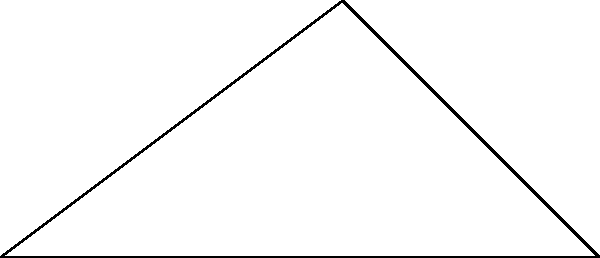During a match against Brentford, Ashley "Bayzo" Bayes takes a corner kick. The ball's trajectory can be represented by vector $\vec{OA} = \langle 4, 3 \rangle$ and $\vec{OB} = \langle 7, 0 \rangle$. Calculate the angle $\theta$ between these two vectors using the dot product formula. To find the angle between two vectors using the dot product, we can follow these steps:

1) The dot product formula for the angle between two vectors is:

   $$\cos \theta = \frac{\vec{a} \cdot \vec{b}}{|\vec{a}||\vec{b}|}$$

2) Calculate the dot product $\vec{OA} \cdot \vec{OB}$:
   $$\vec{OA} \cdot \vec{OB} = (4)(7) + (3)(0) = 28$$

3) Calculate the magnitudes of the vectors:
   $$|\vec{OA}| = \sqrt{4^2 + 3^2} = \sqrt{25} = 5$$
   $$|\vec{OB}| = \sqrt{7^2 + 0^2} = 7$$

4) Substitute these values into the formula:
   $$\cos \theta = \frac{28}{5 \cdot 7} = \frac{28}{35} = \frac{4}{5} = 0.8$$

5) To find $\theta$, we need to take the inverse cosine (arccos) of both sides:
   $$\theta = \arccos(0.8)$$

6) Using a calculator or computer, we can find:
   $$\theta \approx 36.87^\circ$$

Thus, the angle of Bayzo's kick is approximately 36.87 degrees.
Answer: $36.87^\circ$ 